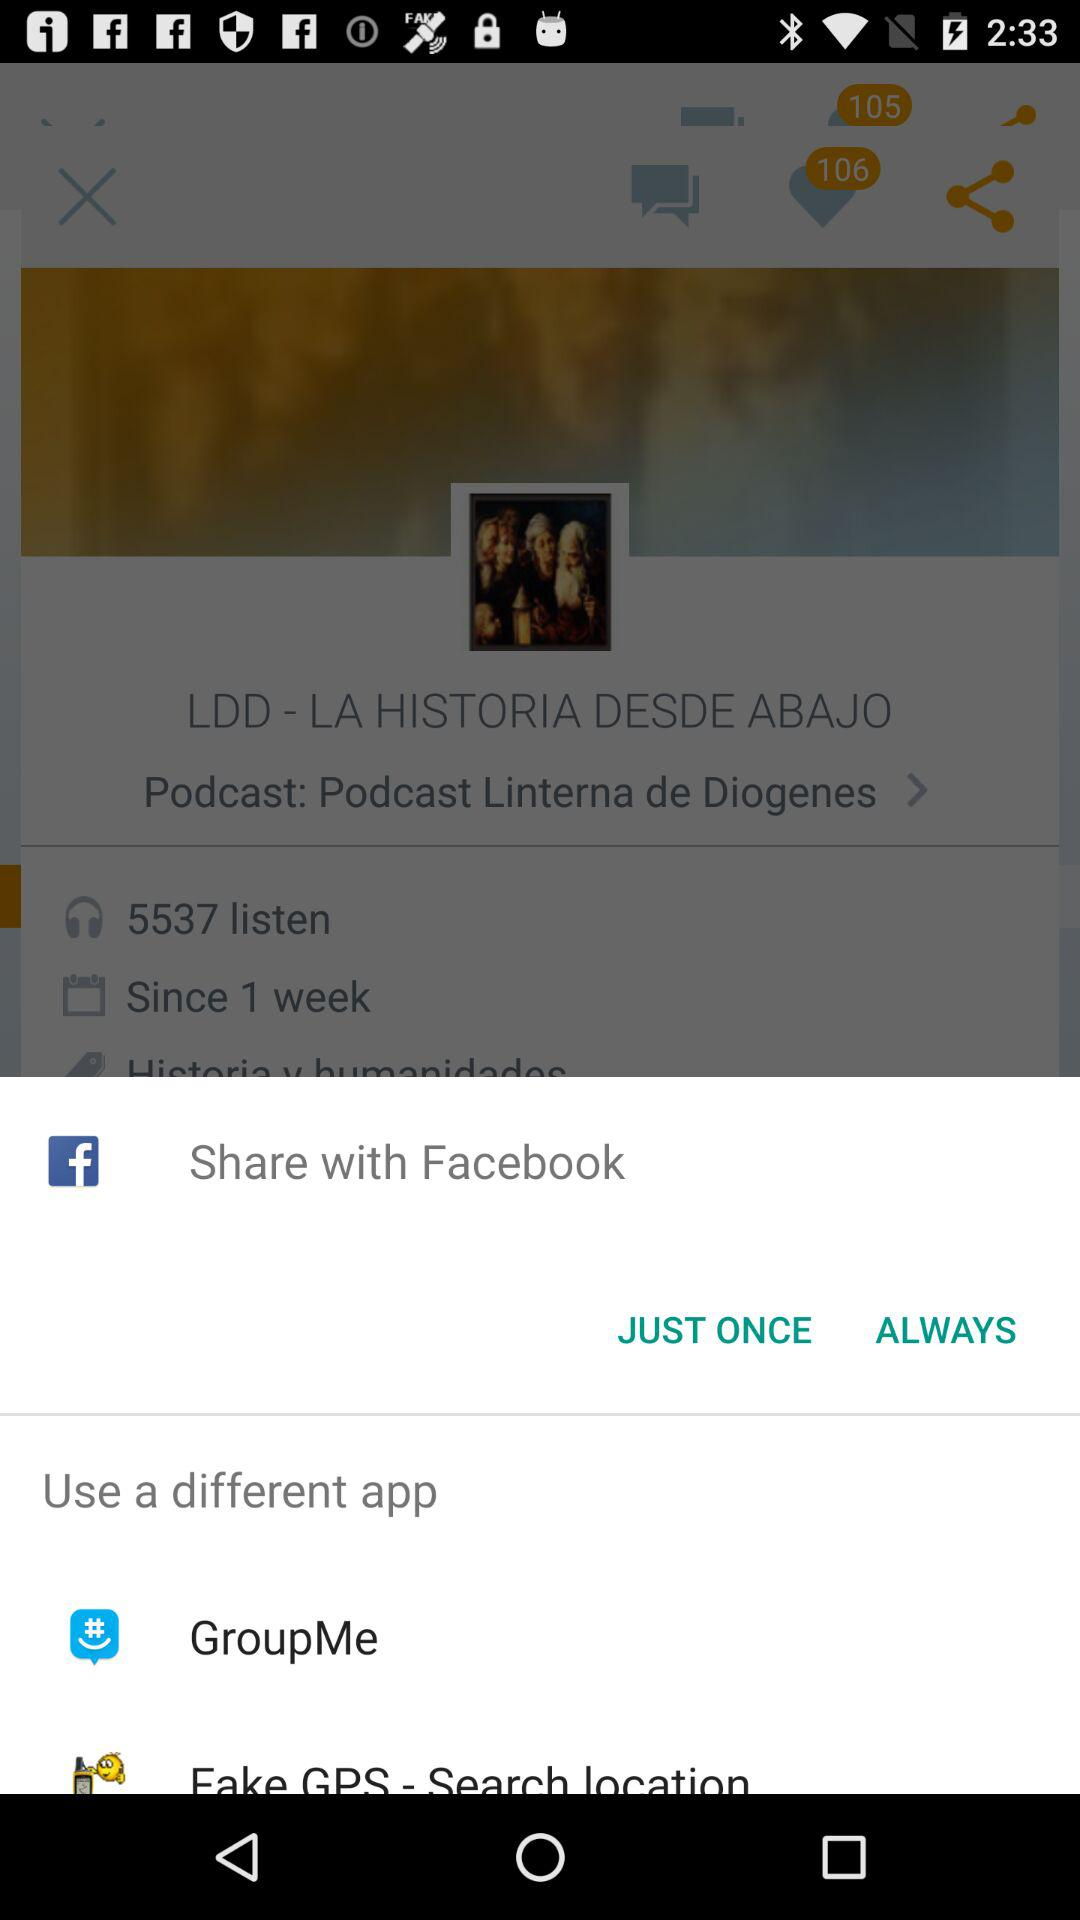What application can I use for sharing the content? You can share it with "Facebook". 